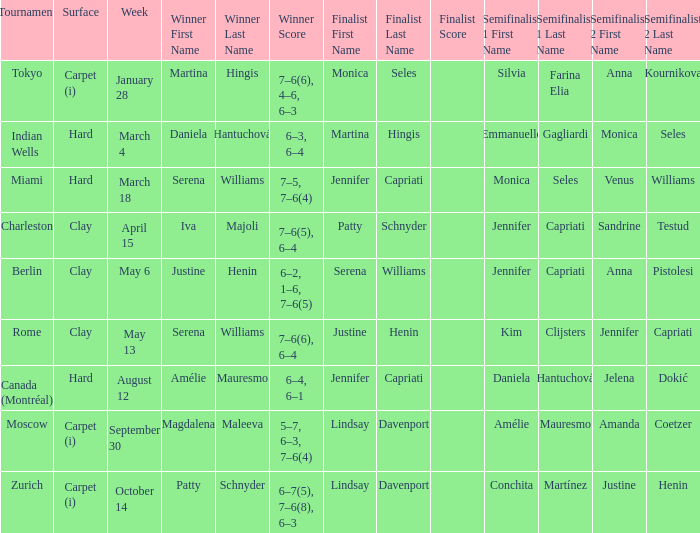What was the surface type for finalist justine henin? Clay. 